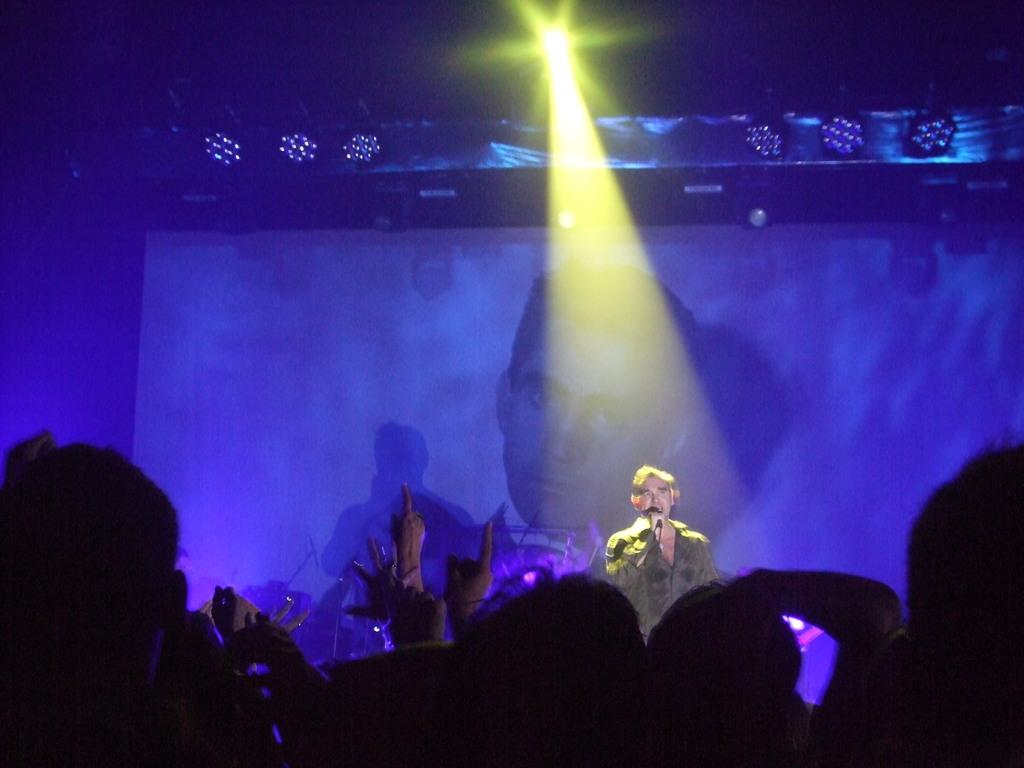What is located at the top of the image? There is a light at the top of the image, and there is also a light ray visible. Are there any other lights in the image besides the one at the top? Yes, there are other lights visible in the image. What can be seen on the screen in the image? The details about the screen cannot be determined from the provided facts. What is the person holding in the image? The person is holding a microphone in the image. Who else is present in the image besides the person with the microphone? There are people at the bottom of the image. What type of trees can be seen in the image? There are no trees present in the image. What route are the people taking in the image? The provided facts do not mention any route or direction of movement for the people in the image. 